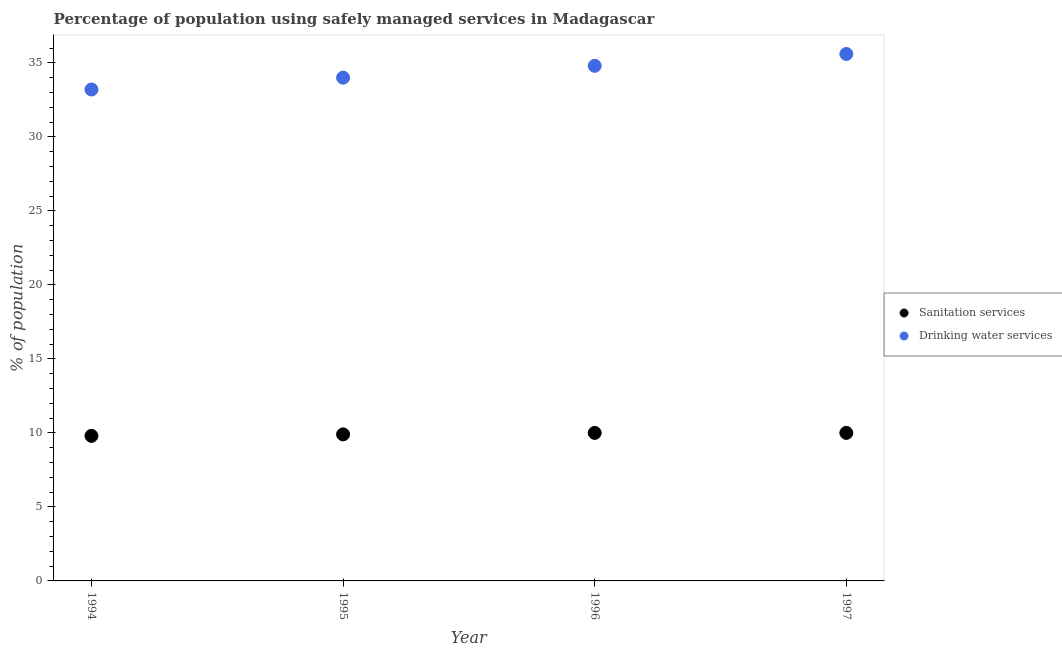How many different coloured dotlines are there?
Your response must be concise. 2. What is the percentage of population who used sanitation services in 1997?
Ensure brevity in your answer.  10. Across all years, what is the maximum percentage of population who used drinking water services?
Ensure brevity in your answer.  35.6. Across all years, what is the minimum percentage of population who used drinking water services?
Offer a very short reply. 33.2. In which year was the percentage of population who used sanitation services minimum?
Provide a succinct answer. 1994. What is the total percentage of population who used sanitation services in the graph?
Make the answer very short. 39.7. What is the difference between the percentage of population who used drinking water services in 1995 and that in 1996?
Make the answer very short. -0.8. What is the difference between the percentage of population who used sanitation services in 1997 and the percentage of population who used drinking water services in 1995?
Make the answer very short. -24. What is the average percentage of population who used drinking water services per year?
Give a very brief answer. 34.4. In the year 1996, what is the difference between the percentage of population who used drinking water services and percentage of population who used sanitation services?
Your answer should be compact. 24.8. In how many years, is the percentage of population who used drinking water services greater than 28 %?
Ensure brevity in your answer.  4. What is the ratio of the percentage of population who used drinking water services in 1994 to that in 1996?
Provide a succinct answer. 0.95. What is the difference between the highest and the lowest percentage of population who used drinking water services?
Provide a succinct answer. 2.4. Is the percentage of population who used sanitation services strictly greater than the percentage of population who used drinking water services over the years?
Your answer should be very brief. No. Is the percentage of population who used drinking water services strictly less than the percentage of population who used sanitation services over the years?
Your answer should be very brief. No. How many dotlines are there?
Provide a succinct answer. 2. How many years are there in the graph?
Your response must be concise. 4. What is the title of the graph?
Ensure brevity in your answer.  Percentage of population using safely managed services in Madagascar. Does "US$" appear as one of the legend labels in the graph?
Ensure brevity in your answer.  No. What is the label or title of the Y-axis?
Your answer should be compact. % of population. What is the % of population in Sanitation services in 1994?
Make the answer very short. 9.8. What is the % of population in Drinking water services in 1994?
Provide a short and direct response. 33.2. What is the % of population in Sanitation services in 1995?
Give a very brief answer. 9.9. What is the % of population in Drinking water services in 1995?
Keep it short and to the point. 34. What is the % of population in Drinking water services in 1996?
Your response must be concise. 34.8. What is the % of population in Drinking water services in 1997?
Your answer should be very brief. 35.6. Across all years, what is the maximum % of population of Drinking water services?
Ensure brevity in your answer.  35.6. Across all years, what is the minimum % of population in Drinking water services?
Offer a terse response. 33.2. What is the total % of population of Sanitation services in the graph?
Give a very brief answer. 39.7. What is the total % of population in Drinking water services in the graph?
Provide a short and direct response. 137.6. What is the difference between the % of population of Sanitation services in 1994 and that in 1995?
Ensure brevity in your answer.  -0.1. What is the difference between the % of population of Sanitation services in 1994 and that in 1997?
Provide a short and direct response. -0.2. What is the difference between the % of population of Drinking water services in 1994 and that in 1997?
Your answer should be compact. -2.4. What is the difference between the % of population of Sanitation services in 1995 and that in 1996?
Your answer should be compact. -0.1. What is the difference between the % of population in Drinking water services in 1995 and that in 1997?
Give a very brief answer. -1.6. What is the difference between the % of population of Sanitation services in 1996 and that in 1997?
Your response must be concise. 0. What is the difference between the % of population of Sanitation services in 1994 and the % of population of Drinking water services in 1995?
Your response must be concise. -24.2. What is the difference between the % of population in Sanitation services in 1994 and the % of population in Drinking water services in 1996?
Offer a terse response. -25. What is the difference between the % of population in Sanitation services in 1994 and the % of population in Drinking water services in 1997?
Offer a very short reply. -25.8. What is the difference between the % of population of Sanitation services in 1995 and the % of population of Drinking water services in 1996?
Your response must be concise. -24.9. What is the difference between the % of population of Sanitation services in 1995 and the % of population of Drinking water services in 1997?
Offer a terse response. -25.7. What is the difference between the % of population in Sanitation services in 1996 and the % of population in Drinking water services in 1997?
Give a very brief answer. -25.6. What is the average % of population in Sanitation services per year?
Offer a terse response. 9.93. What is the average % of population in Drinking water services per year?
Offer a terse response. 34.4. In the year 1994, what is the difference between the % of population of Sanitation services and % of population of Drinking water services?
Offer a terse response. -23.4. In the year 1995, what is the difference between the % of population in Sanitation services and % of population in Drinking water services?
Your answer should be very brief. -24.1. In the year 1996, what is the difference between the % of population of Sanitation services and % of population of Drinking water services?
Offer a very short reply. -24.8. In the year 1997, what is the difference between the % of population of Sanitation services and % of population of Drinking water services?
Ensure brevity in your answer.  -25.6. What is the ratio of the % of population of Drinking water services in 1994 to that in 1995?
Your answer should be very brief. 0.98. What is the ratio of the % of population in Drinking water services in 1994 to that in 1996?
Offer a very short reply. 0.95. What is the ratio of the % of population of Sanitation services in 1994 to that in 1997?
Offer a terse response. 0.98. What is the ratio of the % of population of Drinking water services in 1994 to that in 1997?
Offer a terse response. 0.93. What is the ratio of the % of population in Drinking water services in 1995 to that in 1996?
Your answer should be compact. 0.98. What is the ratio of the % of population in Sanitation services in 1995 to that in 1997?
Ensure brevity in your answer.  0.99. What is the ratio of the % of population of Drinking water services in 1995 to that in 1997?
Provide a short and direct response. 0.96. What is the ratio of the % of population of Sanitation services in 1996 to that in 1997?
Ensure brevity in your answer.  1. What is the ratio of the % of population of Drinking water services in 1996 to that in 1997?
Offer a terse response. 0.98. What is the difference between the highest and the second highest % of population in Sanitation services?
Your answer should be very brief. 0. What is the difference between the highest and the lowest % of population in Sanitation services?
Make the answer very short. 0.2. What is the difference between the highest and the lowest % of population in Drinking water services?
Keep it short and to the point. 2.4. 